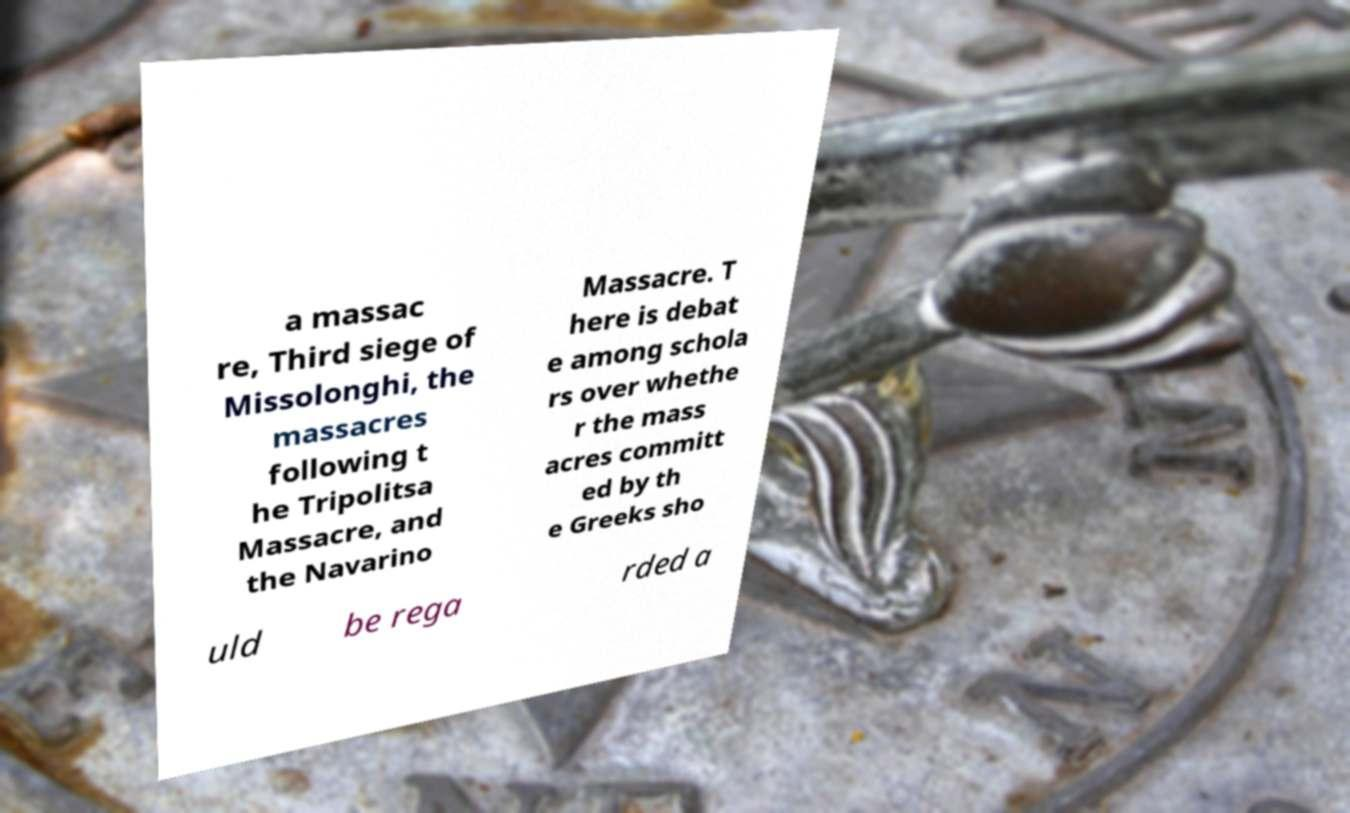What messages or text are displayed in this image? I need them in a readable, typed format. a massac re, Third siege of Missolonghi, the massacres following t he Tripolitsa Massacre, and the Navarino Massacre. T here is debat e among schola rs over whethe r the mass acres committ ed by th e Greeks sho uld be rega rded a 